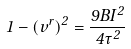Convert formula to latex. <formula><loc_0><loc_0><loc_500><loc_500>1 - ( v ^ { r } ) ^ { 2 } = \frac { 9 B I ^ { 2 } } { 4 \dot { \tau } ^ { 2 } }</formula> 